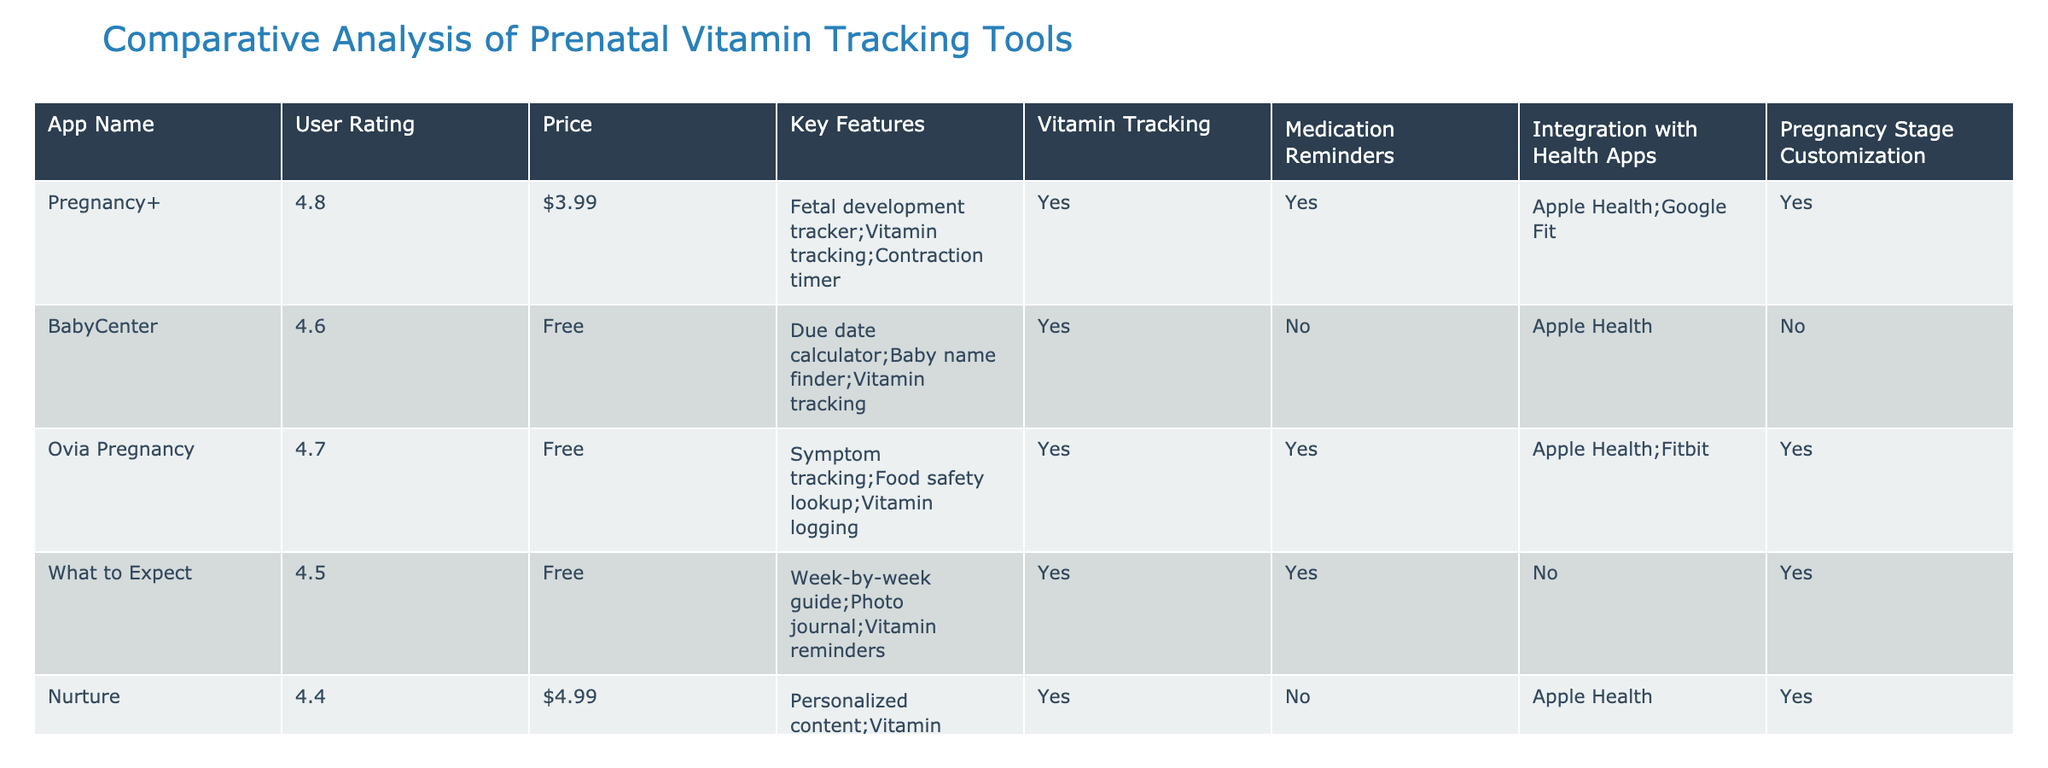What is the highest user rating among the apps? The highest user rating listed in the table is 4.8, which corresponds to the app "Pregnancy+".
Answer: 4.8 Which app has a medication reminders feature but is not free? The app "Pregnancy Assistant" has a medication reminders feature and is priced at $2.99.
Answer: Pregnancy Assistant How many apps offer integration with Health Apps? In the table, 6 apps out of 10 offer integration with Health Apps.
Answer: 6 Does the app "BabyCenter" offer pregnancy stage customization? Looking at the table, "BabyCenter" is marked "No" for pregnancy stage customization.
Answer: No Which app has the lowest user rating and what is it? The app with the lowest user rating is "Pregnancy Assistant" at 4.1.
Answer: 4.1 How much do the two highest-rated apps cost? "Pregnancy+" costs $3.99 and "Ovia Pregnancy" is free. Summing these gives a total cost of $3.99.
Answer: $3.99 Which apps offer both vitamin tracking and medication reminders? The apps that provide both features are "Pregnancy+", "Ovia Pregnancy", "What to Expect", "Pregnancy Tracker", and "Glow Nurture". that makes it 5 apps in total.
Answer: 5 What percentage of the apps are free? There are 6 free apps out of 10 total apps, which is (6/10) * 100 = 60%.
Answer: 60% Is there an app that provides vitamin tracking, is free, and has no medication reminders? Yes, "Preglife" provides vitamin tracking, is free, and has no medication reminders.
Answer: Yes Among the apps that are free, which one has the highest user rating? The app "Ovia Pregnancy" has the highest user rating among the free apps at 4.7.
Answer: 4.7 